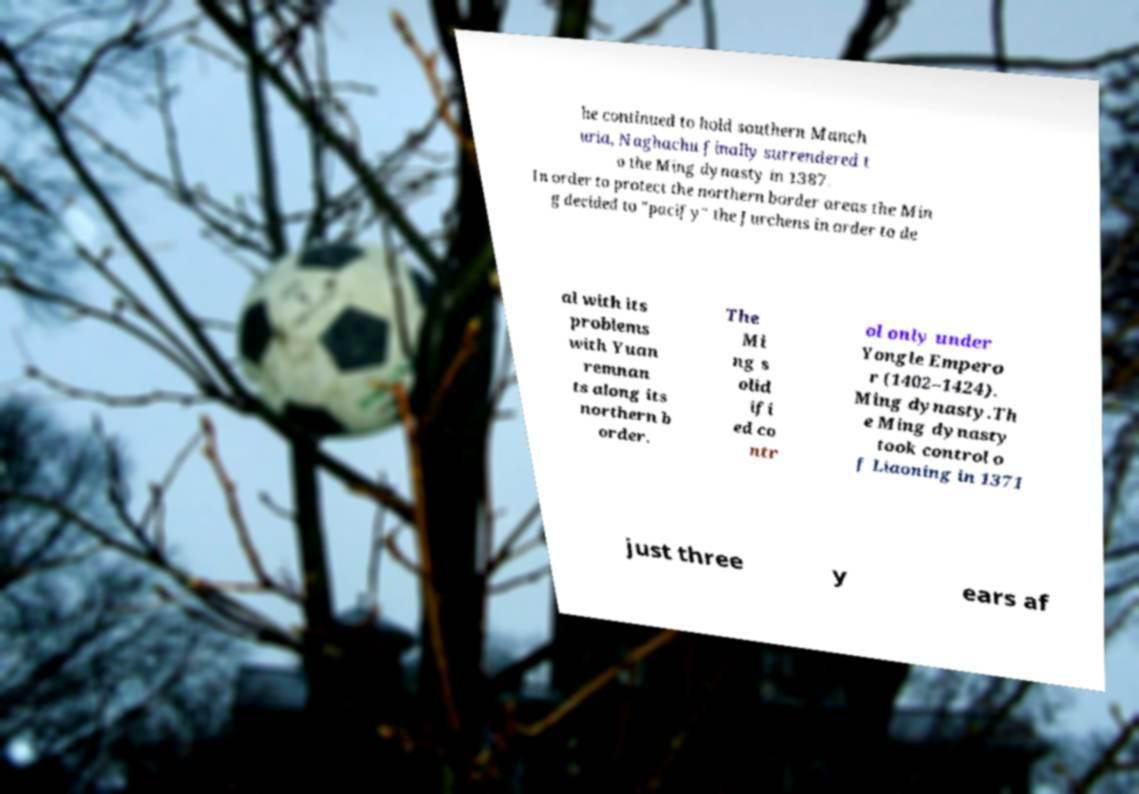Could you extract and type out the text from this image? he continued to hold southern Manch uria, Naghachu finally surrendered t o the Ming dynasty in 1387. In order to protect the northern border areas the Min g decided to "pacify" the Jurchens in order to de al with its problems with Yuan remnan ts along its northern b order. The Mi ng s olid ifi ed co ntr ol only under Yongle Empero r (1402–1424). Ming dynasty.Th e Ming dynasty took control o f Liaoning in 1371 just three y ears af 